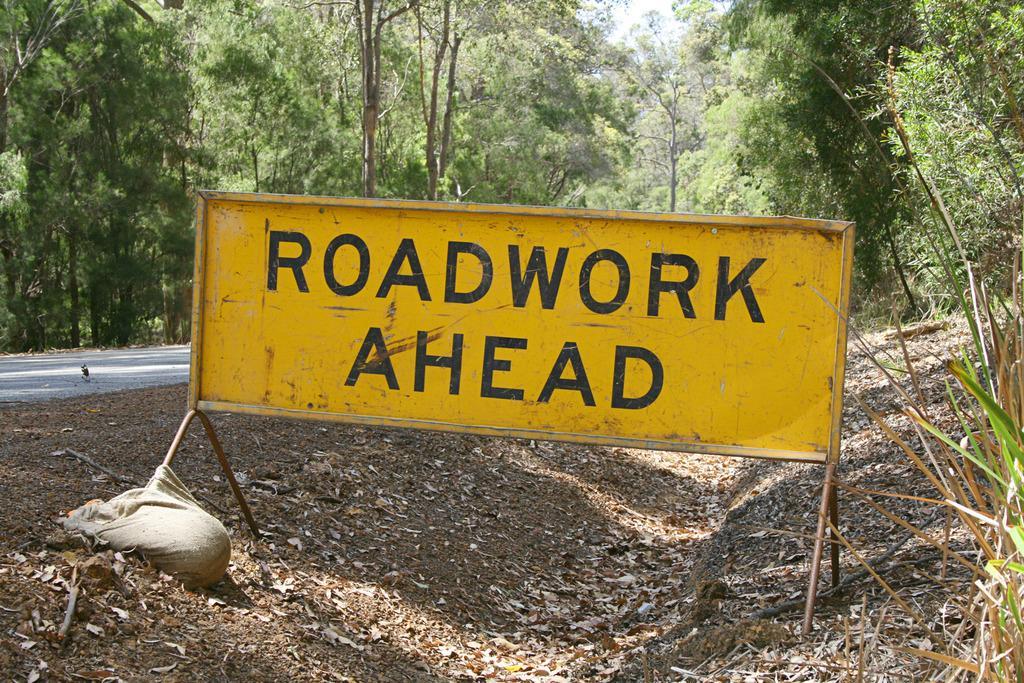How would you summarize this image in a sentence or two? In this image I can see the yellow color board, cloth and the grass. To the left I can see the road. In the background there are many trees and the sky. 